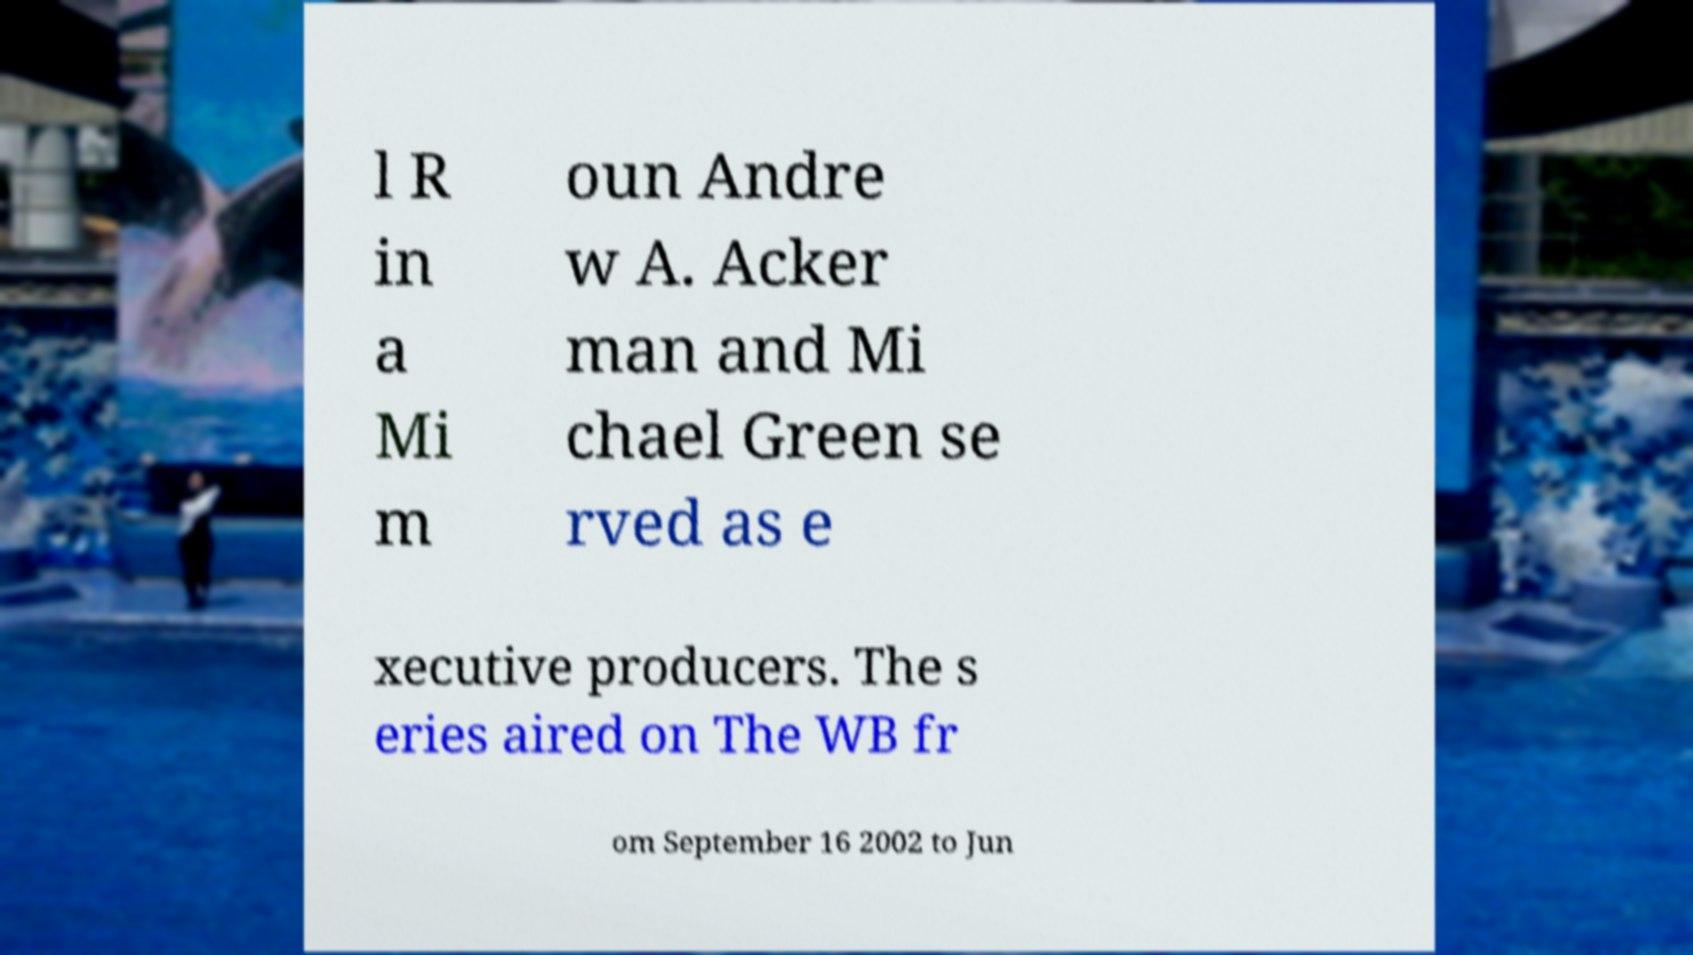There's text embedded in this image that I need extracted. Can you transcribe it verbatim? l R in a Mi m oun Andre w A. Acker man and Mi chael Green se rved as e xecutive producers. The s eries aired on The WB fr om September 16 2002 to Jun 